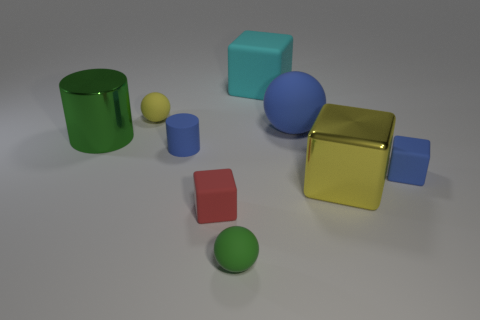There is a tiny matte object that is to the right of the tiny red matte cube and behind the yellow metallic thing; what is its shape?
Ensure brevity in your answer.  Cube. Is there a green ball of the same size as the red matte object?
Provide a short and direct response. Yes. There is a large shiny cylinder; does it have the same color as the tiny block that is behind the small red matte object?
Ensure brevity in your answer.  No. What is the material of the small blue cylinder?
Your answer should be very brief. Rubber. What color is the small ball to the left of the green matte object?
Keep it short and to the point. Yellow. What number of other metallic cylinders are the same color as the big shiny cylinder?
Keep it short and to the point. 0. What number of small matte objects are both behind the green cylinder and in front of the large rubber ball?
Your response must be concise. 0. What is the shape of the blue thing that is the same size as the blue cube?
Provide a short and direct response. Cylinder. What is the size of the blue matte block?
Keep it short and to the point. Small. What material is the large block behind the large object on the left side of the cube that is behind the large cylinder made of?
Offer a very short reply. Rubber. 